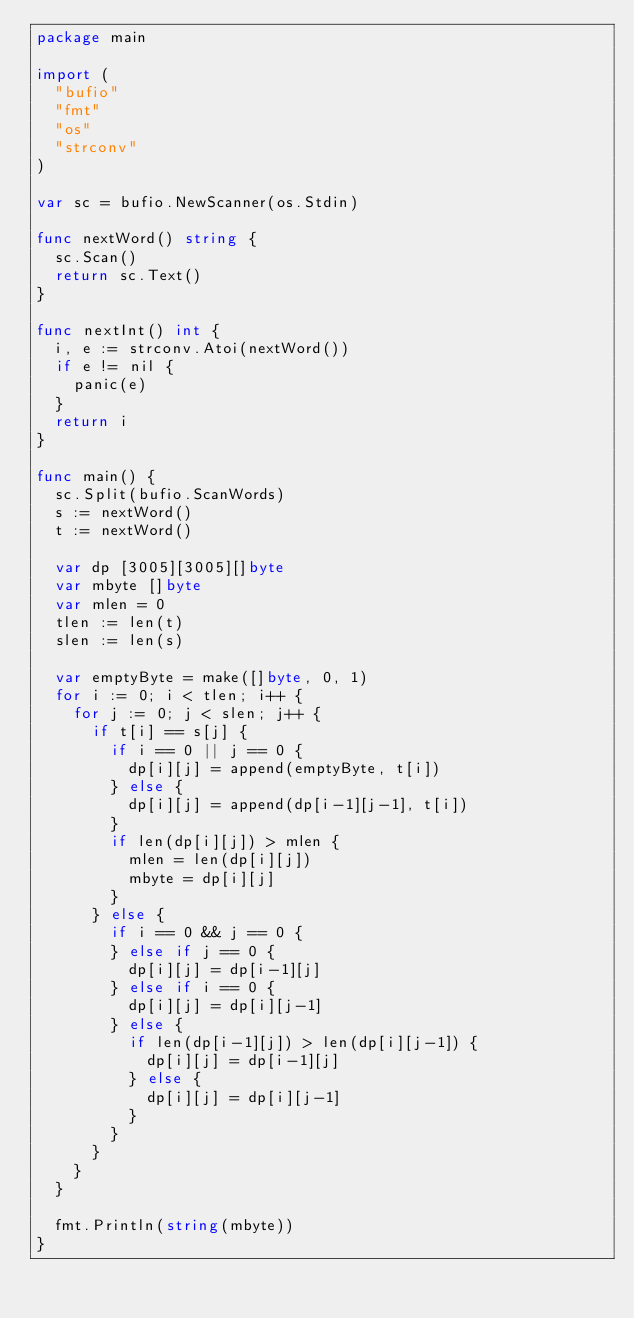Convert code to text. <code><loc_0><loc_0><loc_500><loc_500><_Go_>package main

import (
	"bufio"
	"fmt"
	"os"
	"strconv"
)

var sc = bufio.NewScanner(os.Stdin)

func nextWord() string {
	sc.Scan()
	return sc.Text()
}

func nextInt() int {
	i, e := strconv.Atoi(nextWord())
	if e != nil {
		panic(e)
	}
	return i
}

func main() {
	sc.Split(bufio.ScanWords)
	s := nextWord()
	t := nextWord()

	var dp [3005][3005][]byte
	var mbyte []byte
	var mlen = 0
	tlen := len(t)
	slen := len(s)

	var emptyByte = make([]byte, 0, 1)
	for i := 0; i < tlen; i++ {
		for j := 0; j < slen; j++ {
			if t[i] == s[j] {
				if i == 0 || j == 0 {
					dp[i][j] = append(emptyByte, t[i])
				} else {
					dp[i][j] = append(dp[i-1][j-1], t[i])
				}
				if len(dp[i][j]) > mlen {
					mlen = len(dp[i][j])
					mbyte = dp[i][j]
				}
			} else {
				if i == 0 && j == 0 {
				} else if j == 0 {
					dp[i][j] = dp[i-1][j]
				} else if i == 0 {
					dp[i][j] = dp[i][j-1]
				} else {
					if len(dp[i-1][j]) > len(dp[i][j-1]) {
						dp[i][j] = dp[i-1][j]
					} else {
						dp[i][j] = dp[i][j-1]
					}
				}
			}
		}
	}

	fmt.Println(string(mbyte))
}
</code> 